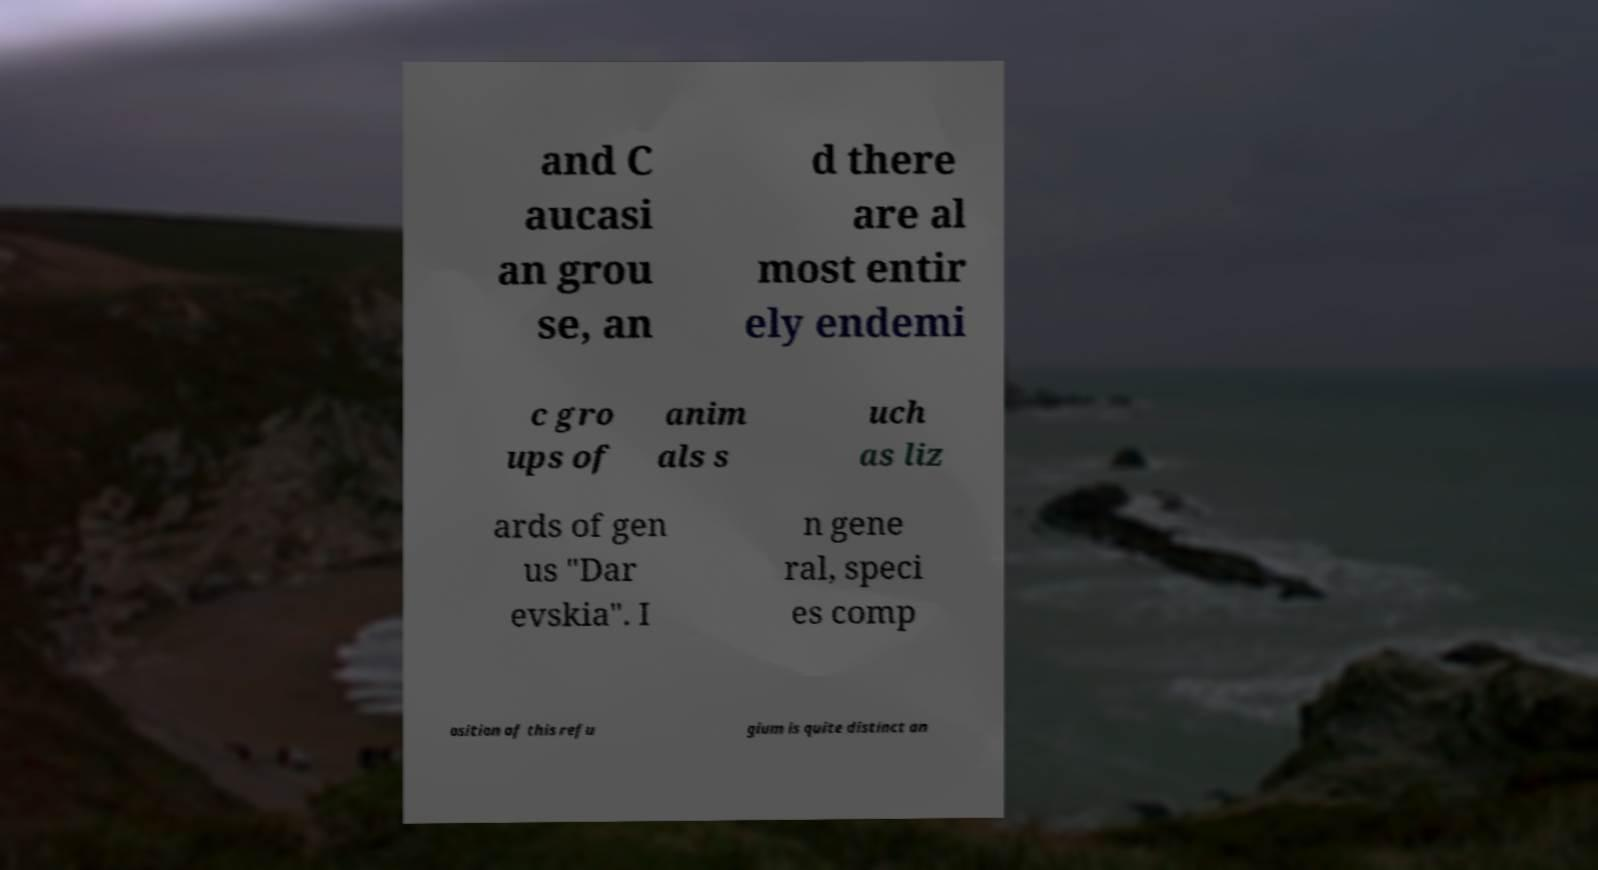For documentation purposes, I need the text within this image transcribed. Could you provide that? and C aucasi an grou se, an d there are al most entir ely endemi c gro ups of anim als s uch as liz ards of gen us "Dar evskia". I n gene ral, speci es comp osition of this refu gium is quite distinct an 